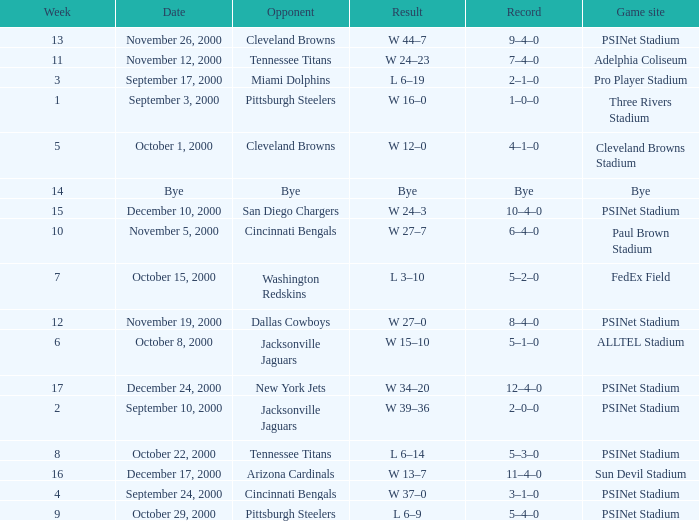What's the record for October 8, 2000 before week 13? 5–1–0. 